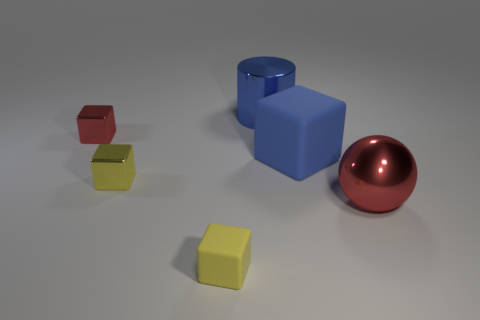How many objects are either large blocks or large yellow metal things?
Ensure brevity in your answer.  1. There is a large object that is on the left side of the large rubber block; does it have the same color as the rubber thing behind the big ball?
Keep it short and to the point. Yes. What is the shape of the other blue object that is the same size as the blue rubber object?
Your answer should be compact. Cylinder. What number of things are tiny yellow things that are in front of the big red metal ball or matte things that are to the left of the big rubber block?
Offer a very short reply. 1. Are there fewer tiny matte objects than large cyan cylinders?
Ensure brevity in your answer.  No. There is a ball that is the same size as the blue block; what is its material?
Provide a short and direct response. Metal. Does the metallic object behind the small red cube have the same size as the metal thing that is right of the metal cylinder?
Make the answer very short. Yes. Are there any other large blocks made of the same material as the large cube?
Your answer should be compact. No. What number of things are tiny objects that are in front of the small yellow metal cube or big blue shiny cylinders?
Your answer should be compact. 2. Is the blue object that is on the right side of the large blue cylinder made of the same material as the small red block?
Your answer should be compact. No. 